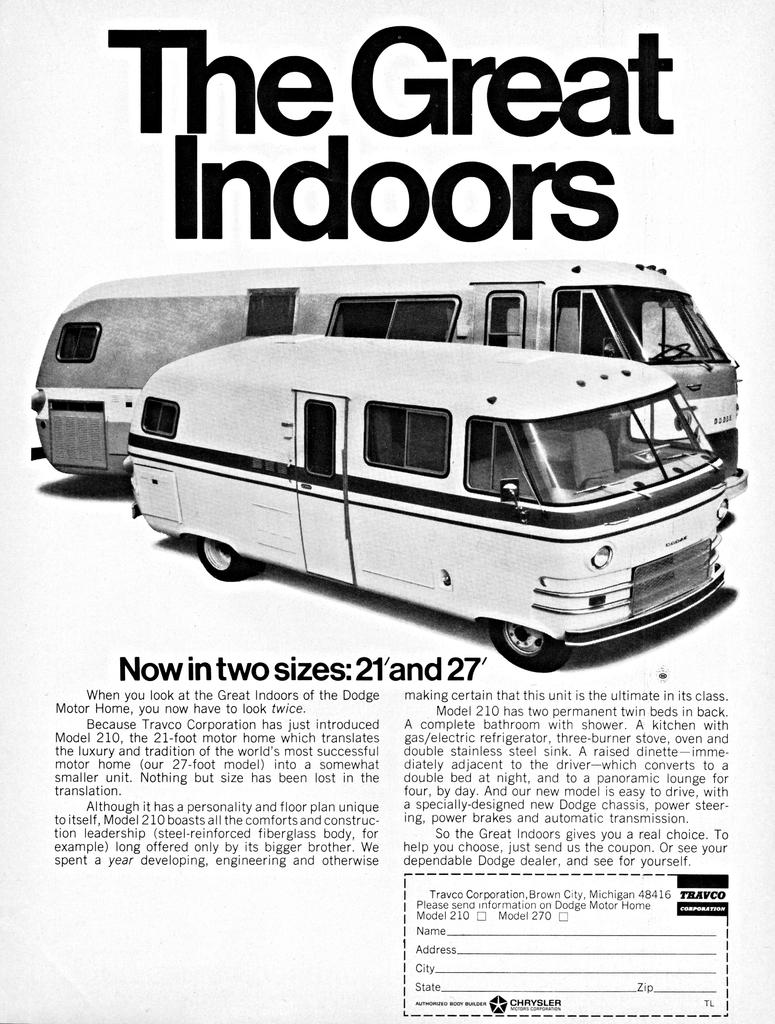<image>
Present a compact description of the photo's key features. A magazine page that titles The Great Outdoors with pictures of old school RVs and featuring a phrase that reads Now in two sizes: 21' and 27' 